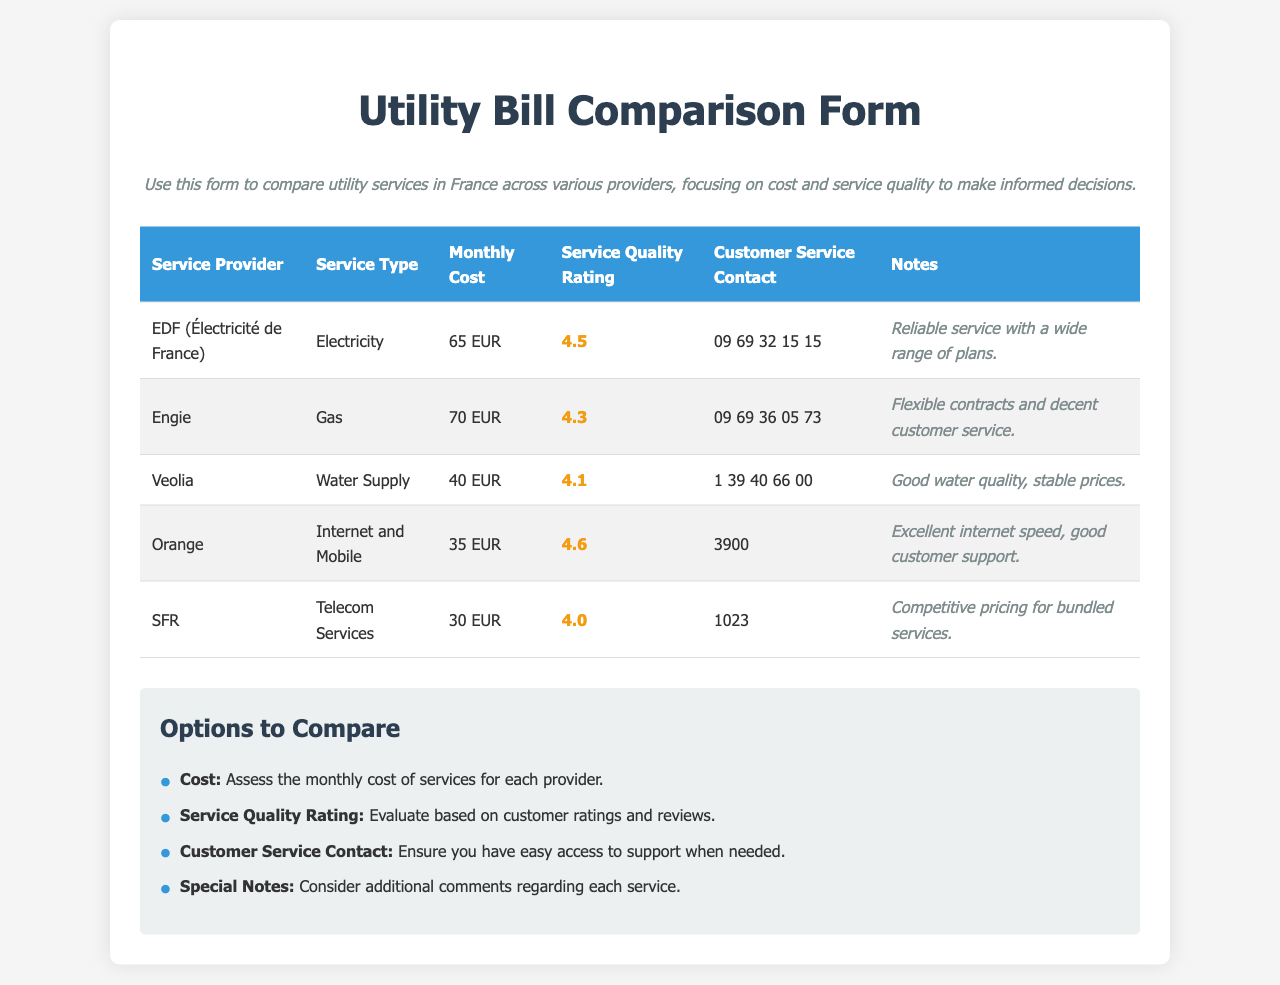What is the monthly cost for EDF? The document lists the monthly cost for EDF (Électricité de France) as 65 EUR.
Answer: 65 EUR What service type does Veolia provide? According to the document, Veolia provides Water Supply services.
Answer: Water Supply Which service provider has the highest service quality rating? The document indicates that Orange has the highest service quality rating of 4.6.
Answer: Orange What is the customer service contact for Engie? The customer service contact for Engie, as per the document, is 09 69 36 05 73.
Answer: 09 69 36 05 73 What is the monthly cost comparison between SFR and Orange? The document states that SFR's monthly cost is 30 EUR and Orange's monthly cost is 35 EUR. SFR is cheaper than Orange.
Answer: SFR is cheaper What additional comments are noted for Veolia? The document mentions that Veolia's water quality is good and prices are stable.
Answer: Good water quality, stable prices Which service type is offered by SFR? The document specifies that SFR offers Telecom Services.
Answer: Telecom Services What are the main comparison points highlighted in the form? The document identifies cost, service quality rating, customer service contact, and special notes as main comparison points.
Answer: Cost, service quality rating, customer service contact, special notes How many service providers are listed in the document? There are five service providers listed in the document.
Answer: Five 